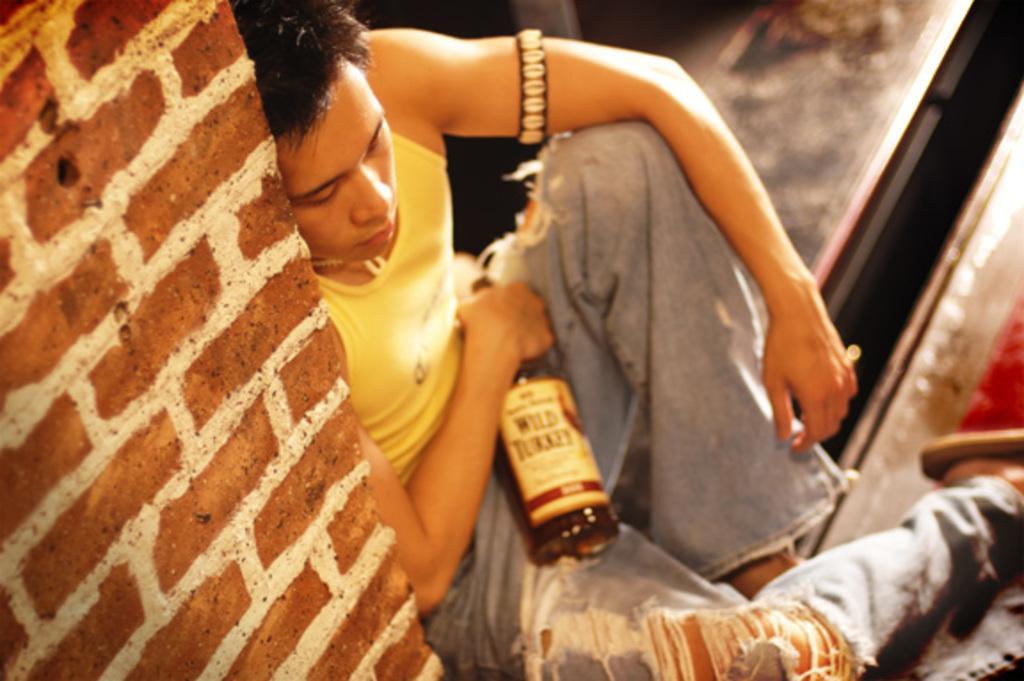Can you describe this image briefly? This picture shows a man seated on the ground and he is holding a bottle with his hand and we see a brick wall and we see a band to his another hand. 